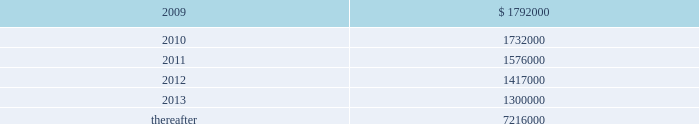Vornado realty trust notes to consolidated financial statements ( continued ) 13 .
Leases as lessor : we lease space to tenants under operating leases .
Most of the leases provide for the payment of fixed base rentals payable monthly in advance .
Office building leases generally require the tenants to reimburse us for operating costs and real estate taxes above their base year costs .
Shopping center leases provide for the pass-through to tenants the tenants 2019 share of real estate taxes , insurance and maintenance .
Shopping center leases also provide for the payment by the lessee of additional rent based on a percentage of the tenants 2019 sales .
As of december 31 , 2008 , future base rental revenue under non-cancelable operating leases , excluding rents for leases with an original term of less than one year and rents resulting from the exercise of renewal options , is as follows : ( amounts in thousands ) year ending december 31: .
These amounts do not include rentals based on tenants 2019 sales .
These percentage rents approximated $ 7322000 , $ 9379000 , and $ 7593000 , for the years ended december 31 , 2008 , 2007 , and 2006 , respectively .
None of our tenants accounted for more than 10% ( 10 % ) of total revenues for the years ended december 31 , 2008 , 2007 and former bradlees locations pursuant to the master agreement and guaranty , dated may 1 , 1992 , we are due $ 5000000 per annum of additional rent from stop & shop which was allocated to certain of bradlees former locations .
On december 31 , 2002 , prior to the expiration of the leases to which the additional rent was allocated , we reallocated this rent to other former bradlees leases also guaranteed by stop & shop .
Stop & shop is contesting our right to reallocate and claims that we are no longer entitled to the additional rent .
At december 31 , 2008 , we are due an aggregate of $ 30400000 .
We believe the additional rent provision of the guaranty expires at the earliest in 2012 and we are vigorously contesting stop & shop 2019s position. .
Percentage rents totaled what in thousands for the years ended december 31 , 2008 and 2007? 
Computations: (7322000 + 9379000)
Answer: 16701000.0. 